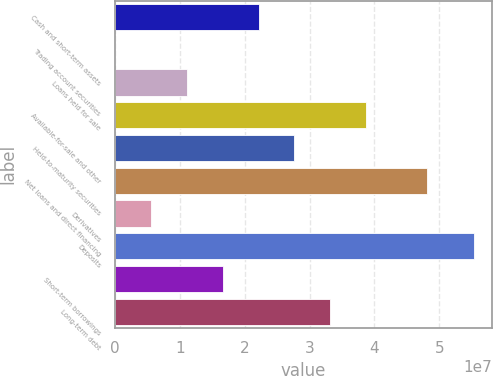<chart> <loc_0><loc_0><loc_500><loc_500><bar_chart><fcel>Cash and short-term assets<fcel>Trading account securities<fcel>Loans held for sale<fcel>Available-for-sale and other<fcel>Held-to-maturity securities<fcel>Net loans and direct financing<fcel>Derivatives<fcel>Deposits<fcel>Short-term borrowings<fcel>Long-term debt<nl><fcel>2.2142e+07<fcel>36997<fcel>1.10895e+07<fcel>3.87207e+07<fcel>2.76682e+07<fcel>4.8025e+07<fcel>5.56324e+06<fcel>5.52994e+07<fcel>1.66157e+07<fcel>3.31945e+07<nl></chart> 